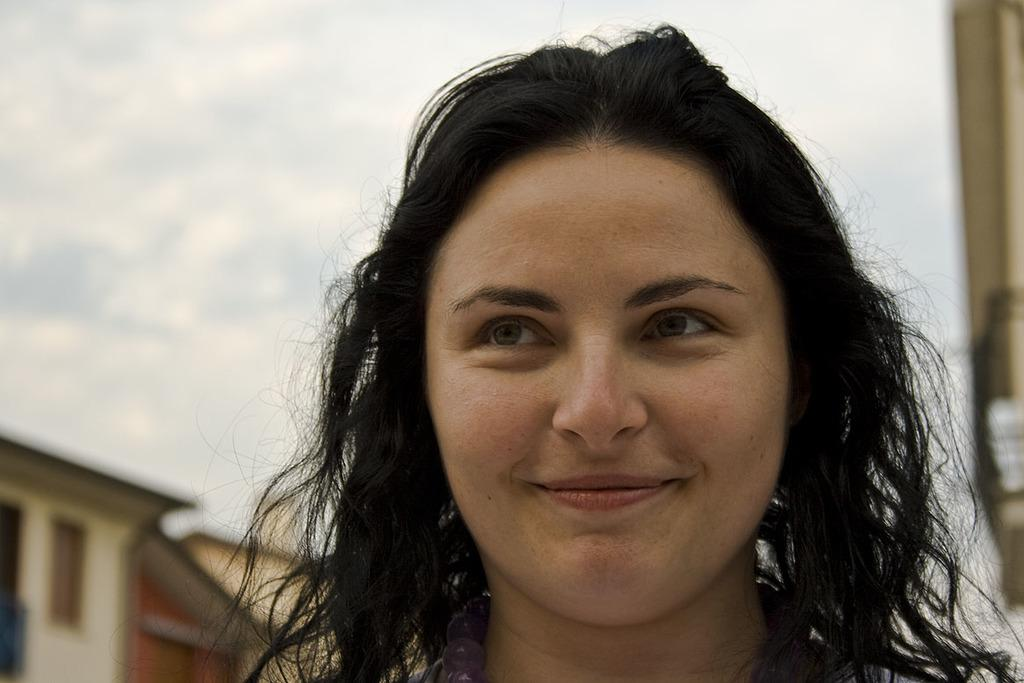What is the expression on the woman's face in the image? The woman in the image is smiling. How would you describe the background of the image? The background of the image is blurred. Can you identify any structures in the background? Yes, there is a house with a window in the background. What is the weather like in the image? The sky is cloudy in the image. How does the jelly burst in the image? There is no jelly present in the image, so it cannot burst. 